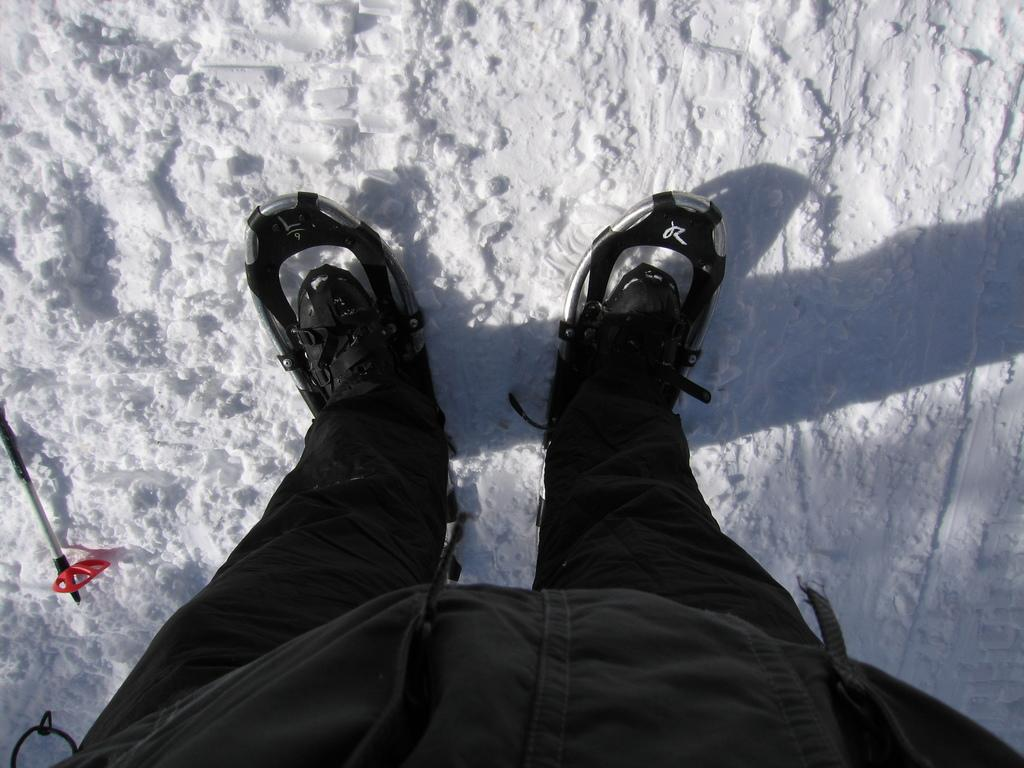What part of a person can be seen in the image? There are legs of a person in the image. What type of weather condition is depicted in the image? There is snow at the bottom of the image. How many mittens can be seen in the image? There are no mittens present in the image. What type of trade is being conducted in the image? There is no trade being conducted in the image; it only shows legs and snow. 